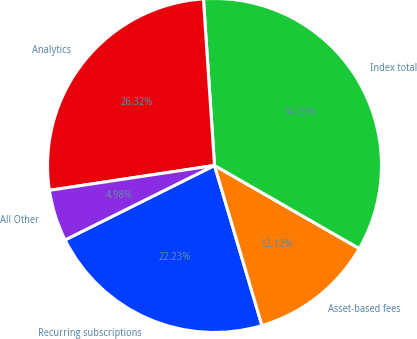Convert chart. <chart><loc_0><loc_0><loc_500><loc_500><pie_chart><fcel>Recurring subscriptions<fcel>Asset-based fees<fcel>Index total<fcel>Analytics<fcel>All Other<nl><fcel>22.23%<fcel>12.12%<fcel>34.35%<fcel>26.32%<fcel>4.98%<nl></chart> 